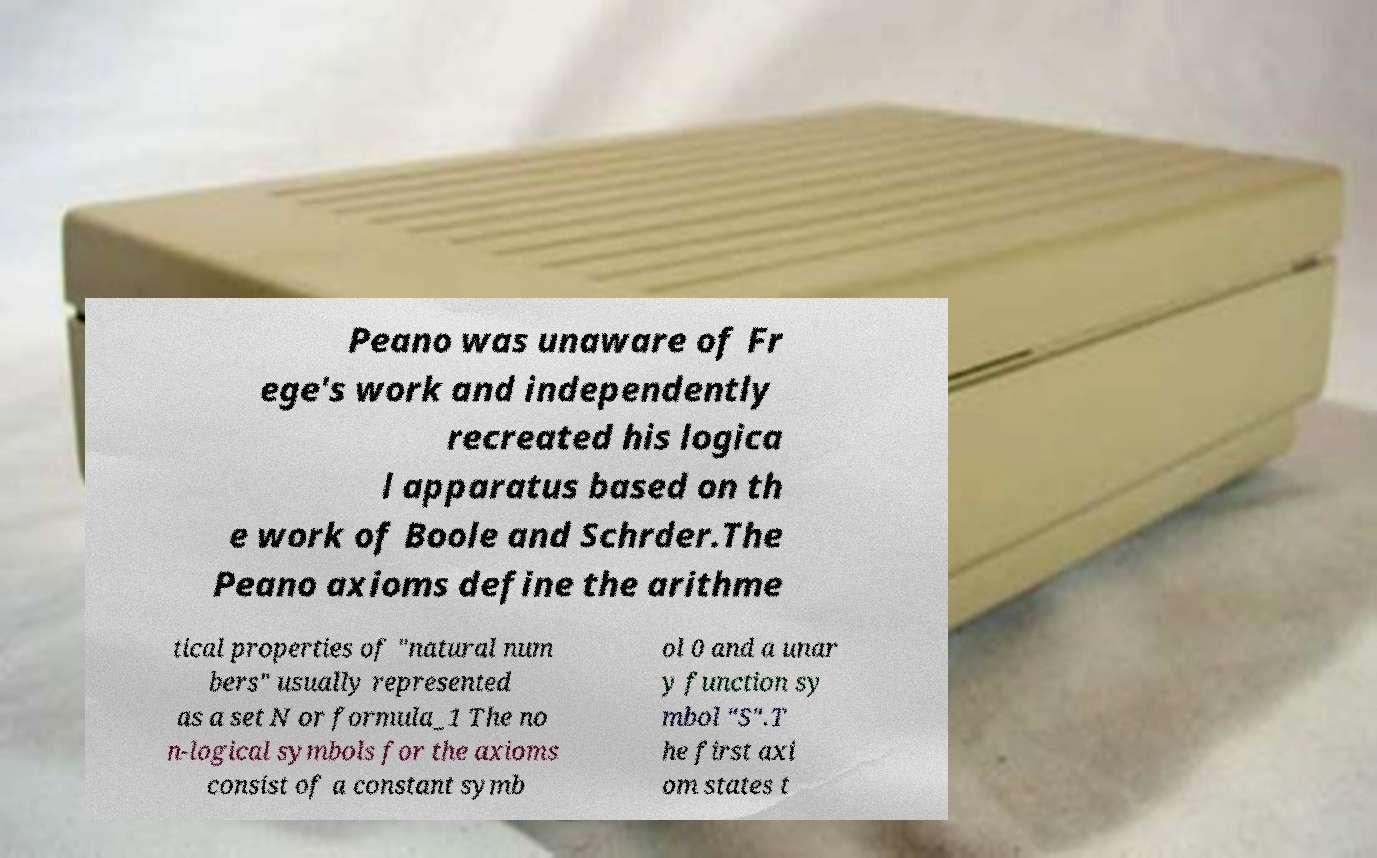What messages or text are displayed in this image? I need them in a readable, typed format. Peano was unaware of Fr ege's work and independently recreated his logica l apparatus based on th e work of Boole and Schrder.The Peano axioms define the arithme tical properties of "natural num bers" usually represented as a set N or formula_1 The no n-logical symbols for the axioms consist of a constant symb ol 0 and a unar y function sy mbol "S".T he first axi om states t 